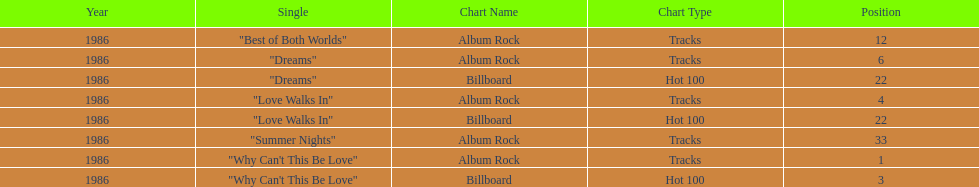Which singles each appear at position 22? Dreams, Love Walks In. 